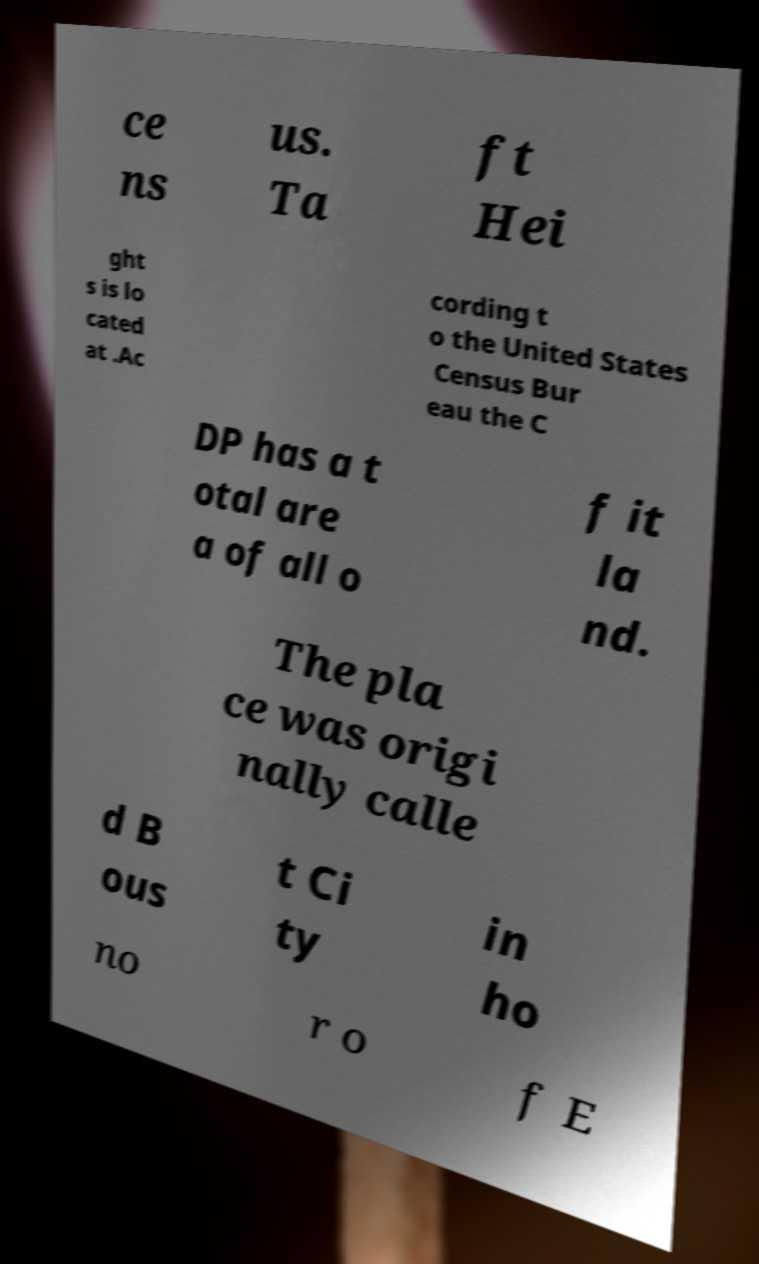What messages or text are displayed in this image? I need them in a readable, typed format. ce ns us. Ta ft Hei ght s is lo cated at .Ac cording t o the United States Census Bur eau the C DP has a t otal are a of all o f it la nd. The pla ce was origi nally calle d B ous t Ci ty in ho no r o f E 